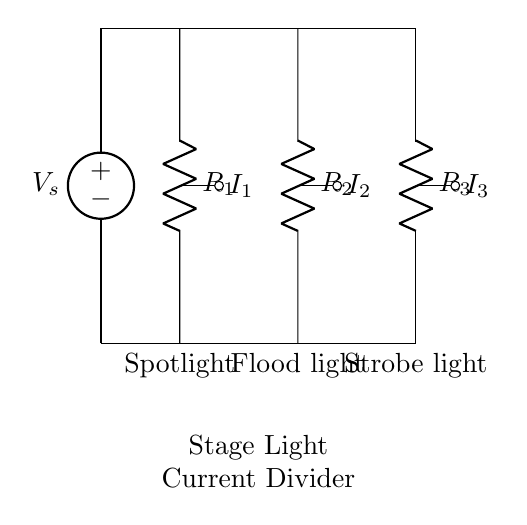What is the voltage source value in this circuit? The voltage source, labeled as V_s, is the supply voltage provided for the circuit. It is typically placed at the top of the circuit representation and can be identified easily.
Answer: V_s How many resistors are present in this circuit? There are three resistors in the circuit, each represented by the labels R1, R2, and R3. These resistors correspond to different stage lights, indicating their parallel arrangement.
Answer: Three What does R1 control? R1 is connected to the spotlight in the circuit, indicating that its resistance influences the current flowing to the spotlight.
Answer: Spotlight If R2 is decreased, what happens to I2? If R2 decreases, according to the current divider rule, the current I2 will increase because less resistance allows more current to flow through that branch. This is based on the inverse relationship between current and resistance in parallel circuits.
Answer: I2 increases Which component would have the highest current? The component with the lowest resistance will have the highest current as current divides inversely to resistance in a parallel circuit. Since we don't have resistor values, we can conclude that if any resistor is lower than the others, it will have the highest current.
Answer: Lowest resistance What is the function of this circuit? The purpose of this parallel circuit is to control the intensity of different stage lights during performances by using a current divider principle where each light receives a portion of the total current based on its resistance.
Answer: Light intensity control What is the total current flowing in the circuit if the source voltage is V_s and the total resistance is a function of R1, R2, and R3? The total current can be calculated using Kirchoff's laws, where the total current is equal to the voltage divided by the equivalent resistance of the parallel resistors (R1, R2, R3). Specific values are needed for an exact numeric answer; generally, the formula is I_total = V_s / R_eq.
Answer: V_s / R_eq 